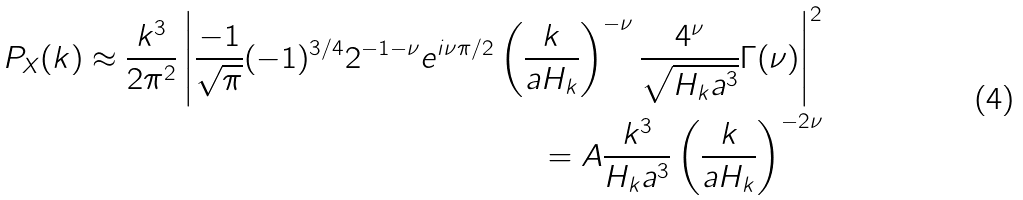Convert formula to latex. <formula><loc_0><loc_0><loc_500><loc_500>P _ { X } ( k ) \approx \frac { k ^ { 3 } } { 2 \pi ^ { 2 } } \left | \frac { - 1 } { \sqrt { \pi } } ( - 1 ) ^ { 3 / 4 } 2 ^ { - 1 - \nu } e ^ { i \nu \pi / 2 } \left ( \frac { k } { a H _ { k } } \right ) ^ { - \nu } \frac { 4 ^ { \nu } } { \sqrt { H _ { k } a ^ { 3 } } } \Gamma ( \nu ) \right | ^ { 2 } \\ = A \frac { k ^ { 3 } } { H _ { k } a ^ { 3 } } \left ( \frac { k } { a H _ { k } } \right ) ^ { - 2 \nu }</formula> 